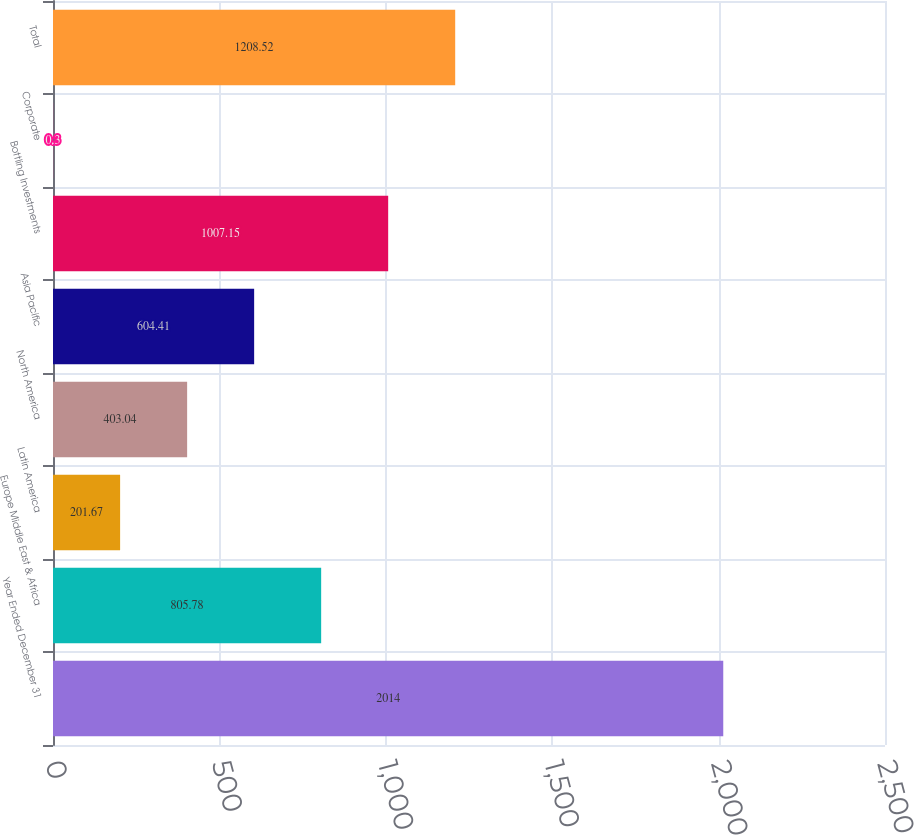Convert chart. <chart><loc_0><loc_0><loc_500><loc_500><bar_chart><fcel>Year Ended December 31<fcel>Europe Middle East & Africa<fcel>Latin America<fcel>North America<fcel>Asia Pacific<fcel>Bottling Investments<fcel>Corporate<fcel>Total<nl><fcel>2014<fcel>805.78<fcel>201.67<fcel>403.04<fcel>604.41<fcel>1007.15<fcel>0.3<fcel>1208.52<nl></chart> 